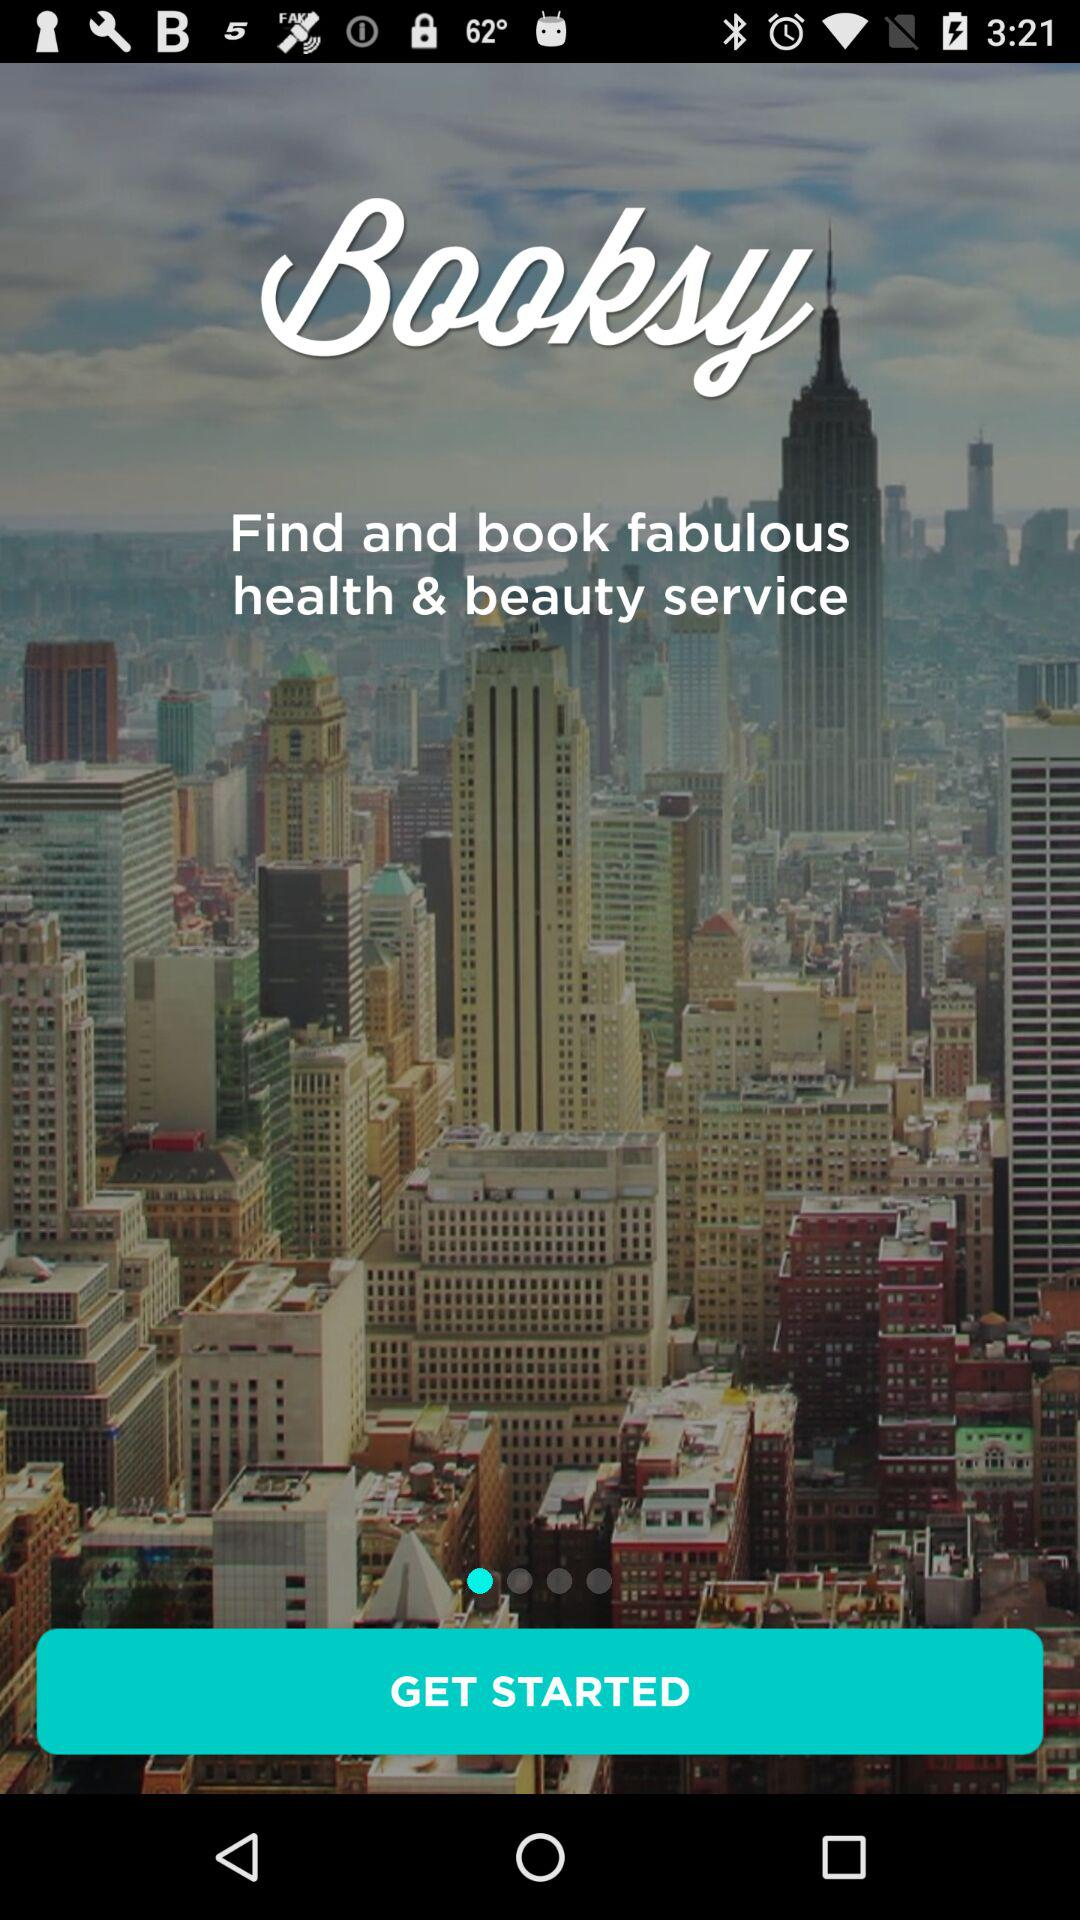What is the application name? The application name is "Booksy". 